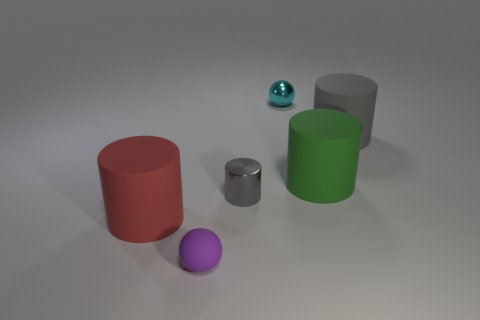How many other small gray objects are made of the same material as the small gray thing?
Provide a short and direct response. 0. What is the color of the tiny ball that is made of the same material as the red cylinder?
Give a very brief answer. Purple. What shape is the green matte thing?
Provide a succinct answer. Cylinder. What number of other shiny cylinders have the same color as the metal cylinder?
Offer a terse response. 0. There is a matte thing that is the same size as the cyan ball; what shape is it?
Keep it short and to the point. Sphere. Is there a yellow rubber cylinder of the same size as the red rubber thing?
Provide a succinct answer. No. There is a cylinder that is the same size as the metal sphere; what material is it?
Your answer should be very brief. Metal. How big is the matte cylinder on the left side of the purple object in front of the big red object?
Your answer should be compact. Large. There is a cylinder that is left of the purple sphere; does it have the same size as the cyan ball?
Offer a very short reply. No. Is the number of purple objects behind the cyan thing greater than the number of red matte things that are behind the big green object?
Ensure brevity in your answer.  No. 